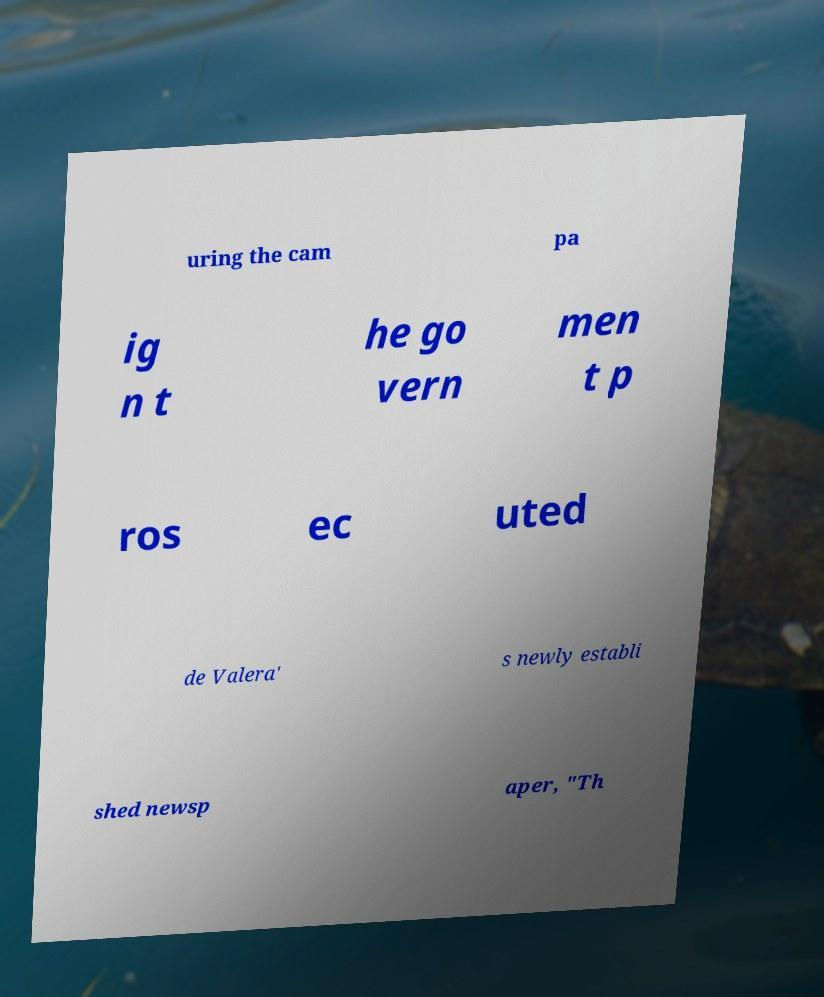There's text embedded in this image that I need extracted. Can you transcribe it verbatim? uring the cam pa ig n t he go vern men t p ros ec uted de Valera' s newly establi shed newsp aper, "Th 